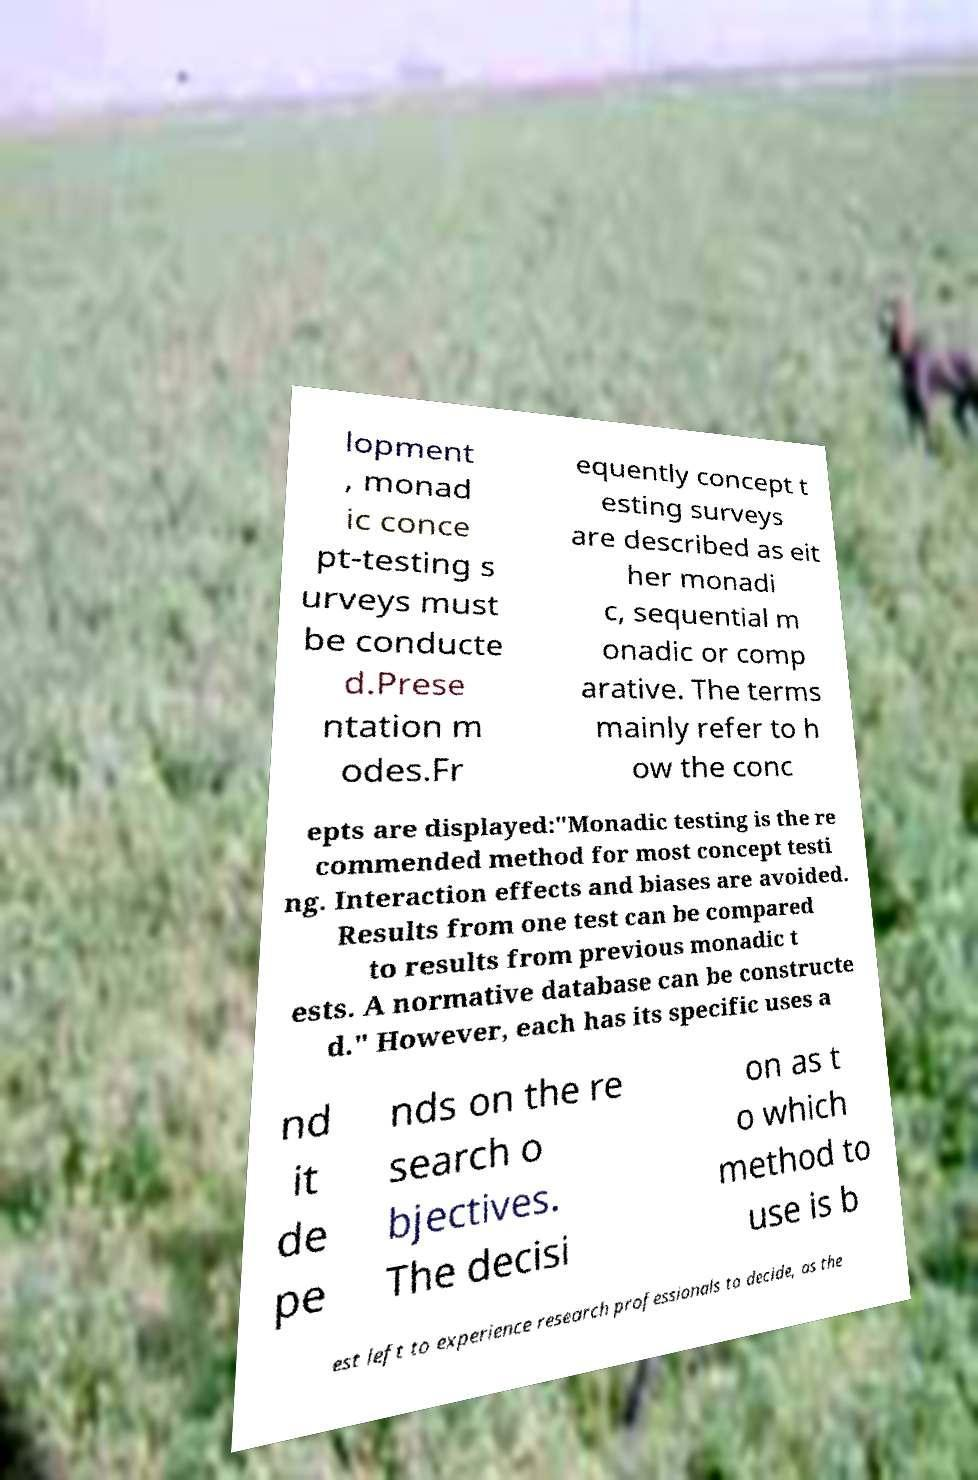For documentation purposes, I need the text within this image transcribed. Could you provide that? lopment , monad ic conce pt-testing s urveys must be conducte d.Prese ntation m odes.Fr equently concept t esting surveys are described as eit her monadi c, sequential m onadic or comp arative. The terms mainly refer to h ow the conc epts are displayed:"Monadic testing is the re commended method for most concept testi ng. Interaction effects and biases are avoided. Results from one test can be compared to results from previous monadic t ests. A normative database can be constructe d." However, each has its specific uses a nd it de pe nds on the re search o bjectives. The decisi on as t o which method to use is b est left to experience research professionals to decide, as the 